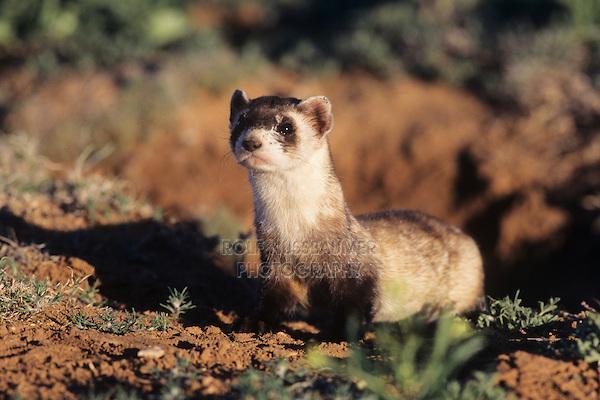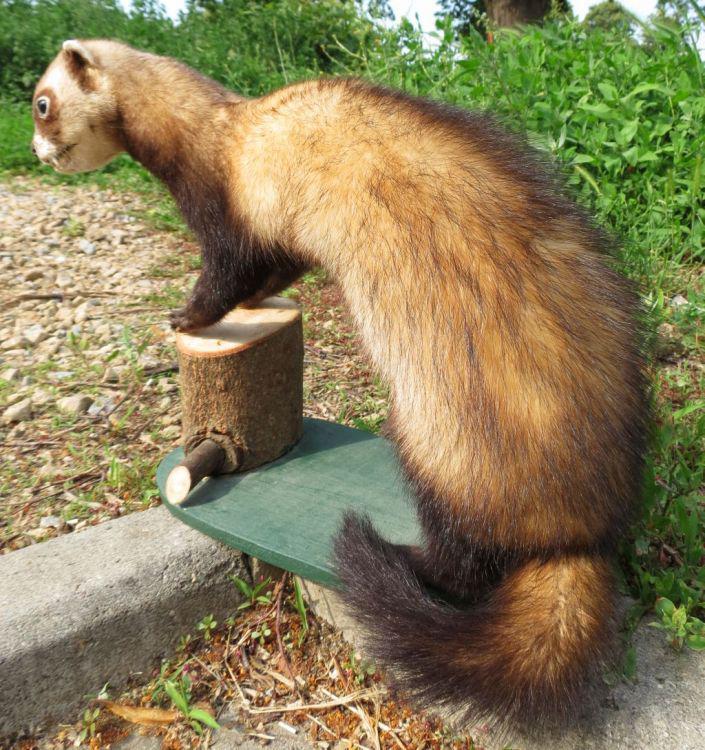The first image is the image on the left, the second image is the image on the right. Assess this claim about the two images: "One of the animal's tail is curved". Correct or not? Answer yes or no. Yes. 